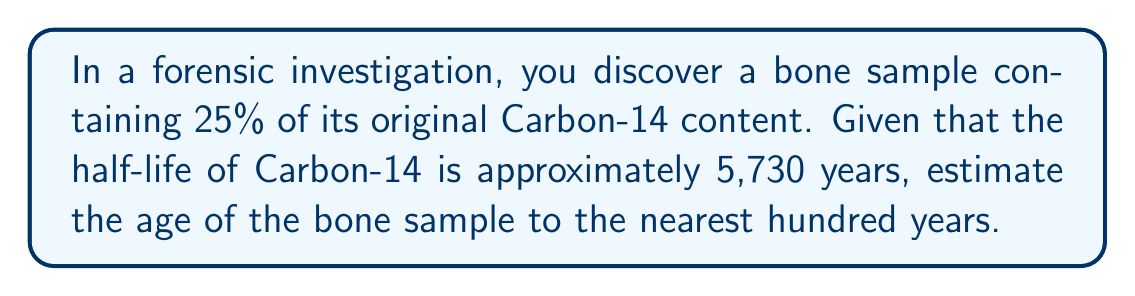Can you answer this question? Let's approach this step-by-step:

1) The half-life equation is:

   $$ A = A_0 \cdot (1/2)^{t/t_{1/2}} $$

   Where:
   $A$ is the remaining amount
   $A_0$ is the initial amount
   $t$ is the time elapsed
   $t_{1/2}$ is the half-life

2) We know:
   - $A/A_0 = 25\% = 0.25$ (remaining fraction)
   - $t_{1/2} = 5,730$ years

3) Substituting into the equation:

   $$ 0.25 = (1/2)^{t/5730} $$

4) Taking the logarithm of both sides:

   $$ \log(0.25) = \log((1/2)^{t/5730}) $$

5) Using the logarithm property $\log(a^b) = b\log(a)$:

   $$ \log(0.25) = (t/5730) \cdot \log(1/2) $$

6) Solving for $t$:

   $$ t = \frac{5730 \cdot \log(0.25)}{\log(1/2)} $$

7) Calculating:

   $$ t \approx 11,460 \text{ years} $$

8) Rounding to the nearest hundred years:

   $$ t \approx 11,500 \text{ years} $$
Answer: $11,500$ years 